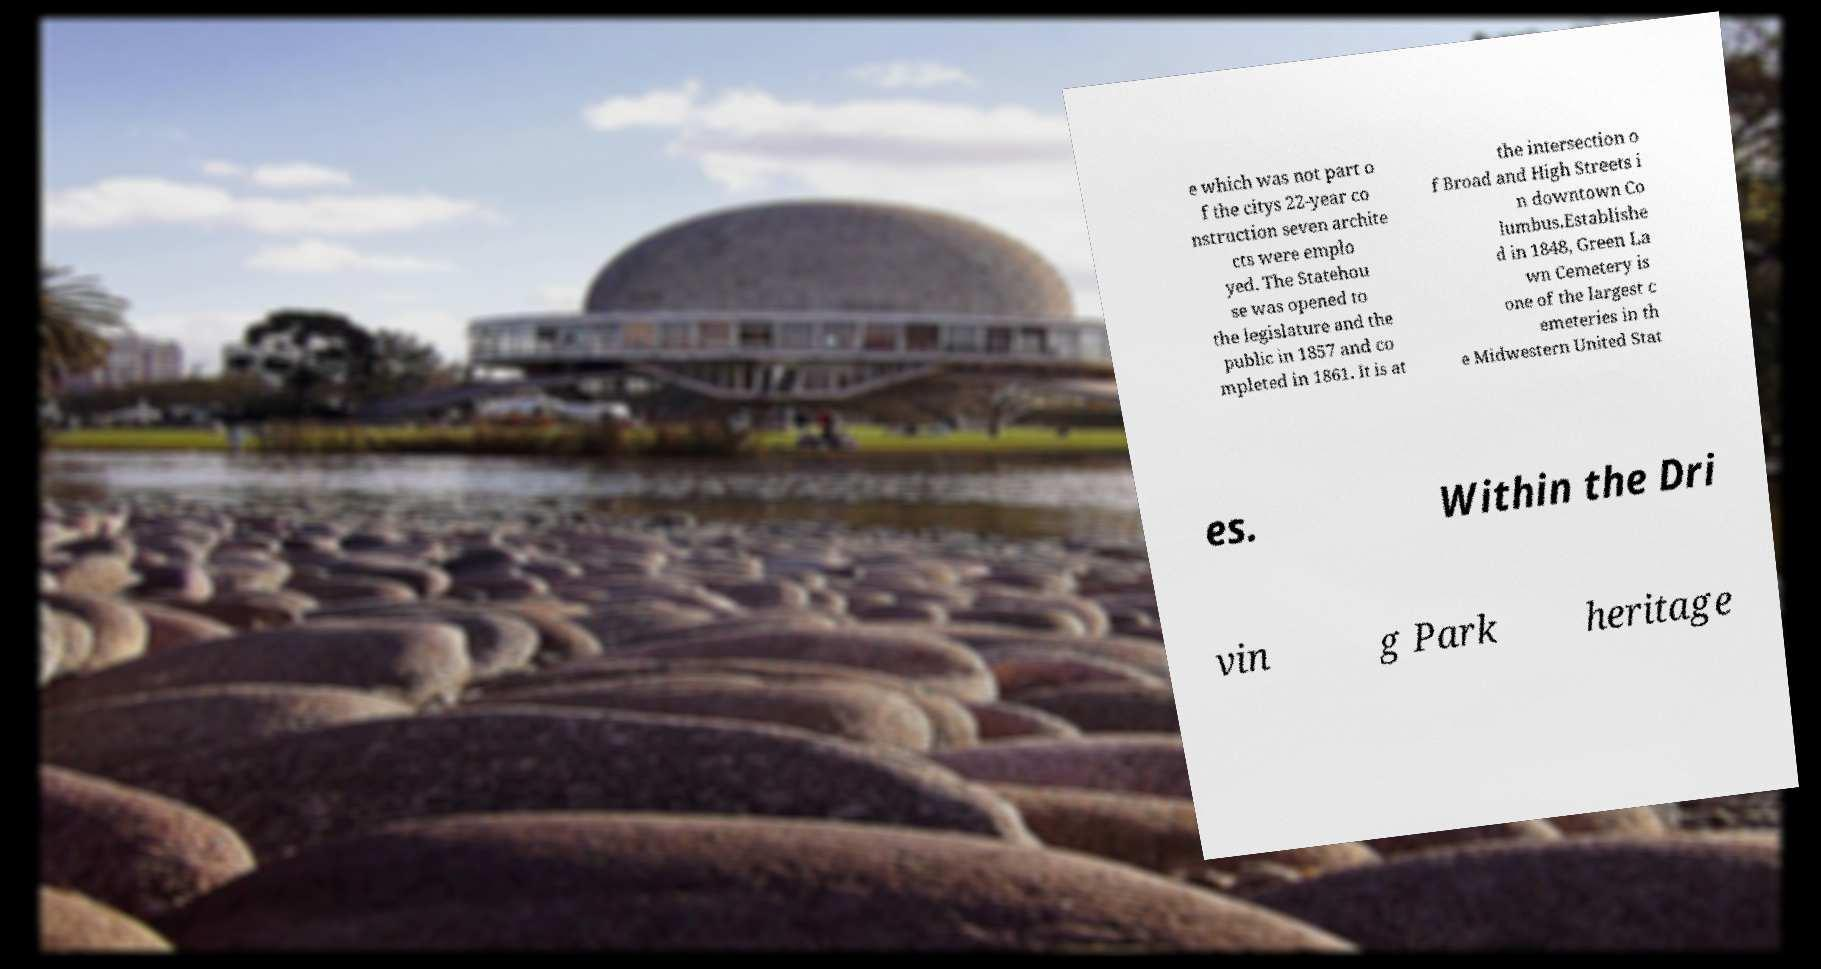What messages or text are displayed in this image? I need them in a readable, typed format. e which was not part o f the citys 22-year co nstruction seven archite cts were emplo yed. The Statehou se was opened to the legislature and the public in 1857 and co mpleted in 1861. It is at the intersection o f Broad and High Streets i n downtown Co lumbus.Establishe d in 1848, Green La wn Cemetery is one of the largest c emeteries in th e Midwestern United Stat es. Within the Dri vin g Park heritage 